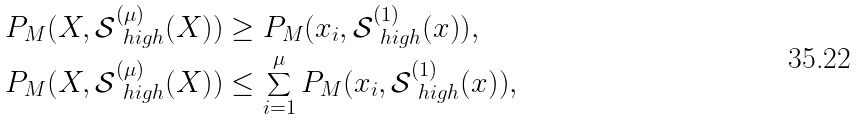<formula> <loc_0><loc_0><loc_500><loc_500>& P _ { M } ( X , \mathcal { S } ^ { ( \mu ) } _ { \ h i g h } ( X ) ) \geq P _ { M } ( x _ { i } , \mathcal { S } ^ { ( 1 ) } _ { \ h i g h } ( x ) ) , \\ & P _ { M } ( X , \mathcal { S } ^ { ( \mu ) } _ { \ h i g h } ( X ) ) \leq \sum ^ { \mu } _ { i = 1 } P _ { M } ( x _ { i } , \mathcal { S } ^ { ( 1 ) } _ { \ h i g h } ( x ) ) ,</formula> 